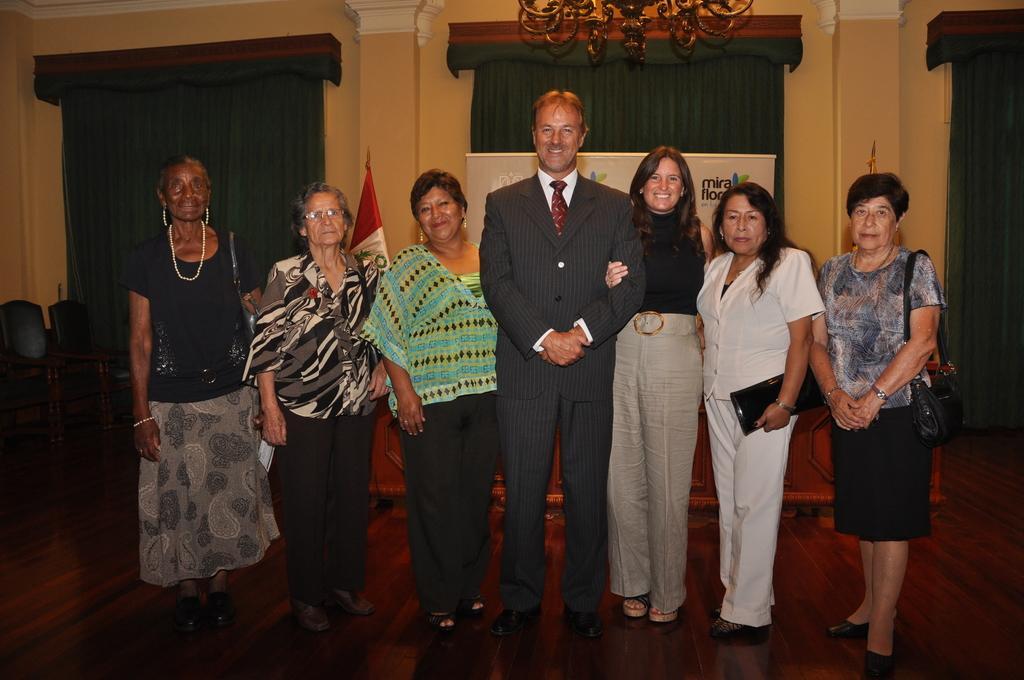Please provide a concise description of this image. There are persons in different color dresses smiling and standing on the floor. In the background, there are chairs arranged in a curtain, there are curtains on the wall and there is a light attached to the roof. 